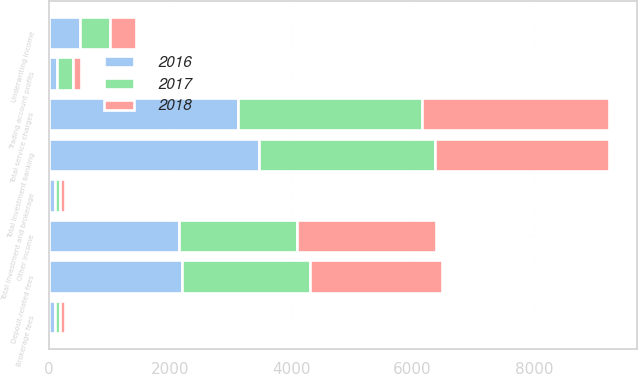Convert chart. <chart><loc_0><loc_0><loc_500><loc_500><stacked_bar_chart><ecel><fcel>Deposit-related fees<fcel>Total service charges<fcel>Brokerage fees<fcel>Total investment and brokerage<fcel>Underwriting income<fcel>Total investment banking<fcel>Trading account profits<fcel>Other income<nl><fcel>2017<fcel>2111<fcel>3027<fcel>94<fcel>94<fcel>502<fcel>2891<fcel>260<fcel>1950<nl><fcel>2016<fcel>2197<fcel>3125<fcel>97<fcel>97<fcel>511<fcel>3471<fcel>134<fcel>2150<nl><fcel>2018<fcel>2170<fcel>3094<fcel>74<fcel>74<fcel>426<fcel>2884<fcel>133<fcel>2286<nl></chart> 